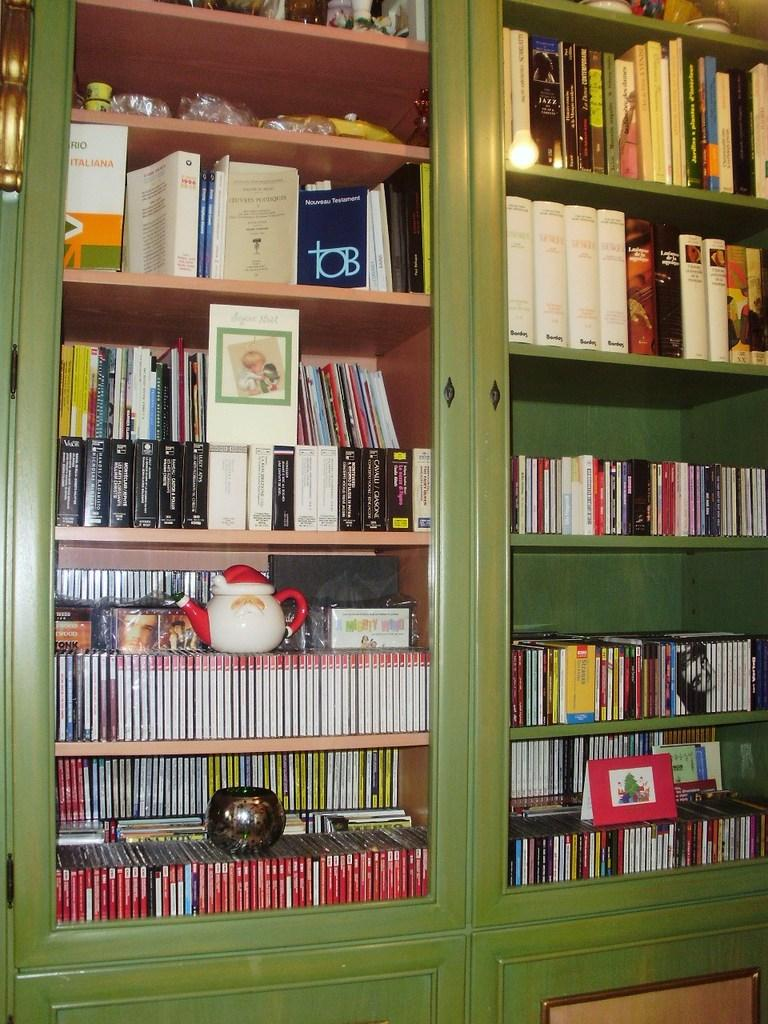<image>
Summarize the visual content of the image. A large green shelf unit includes an Italian version of the New Testament. 